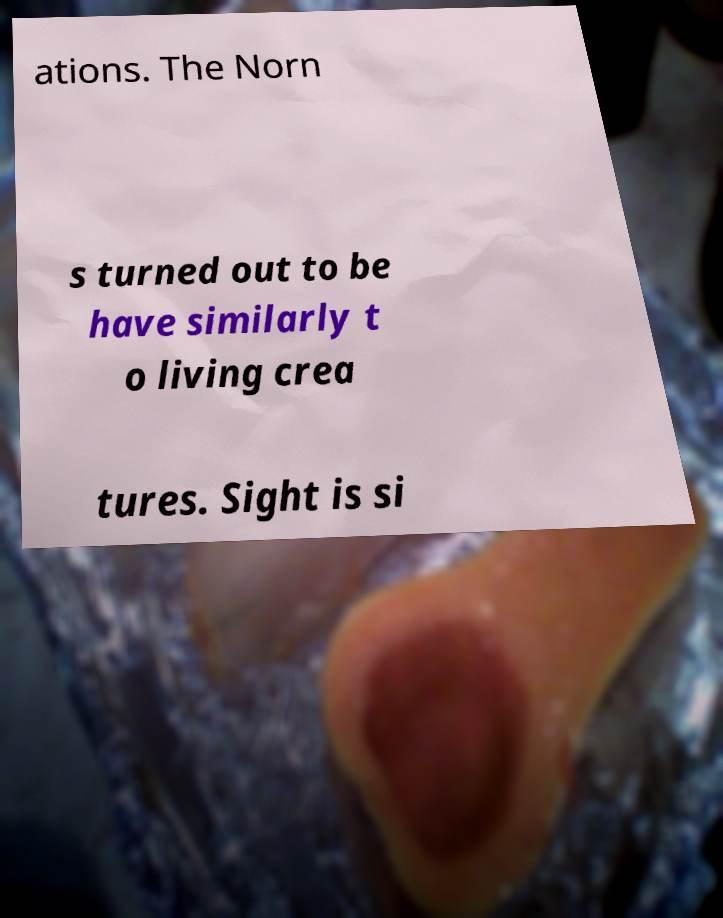Could you extract and type out the text from this image? ations. The Norn s turned out to be have similarly t o living crea tures. Sight is si 